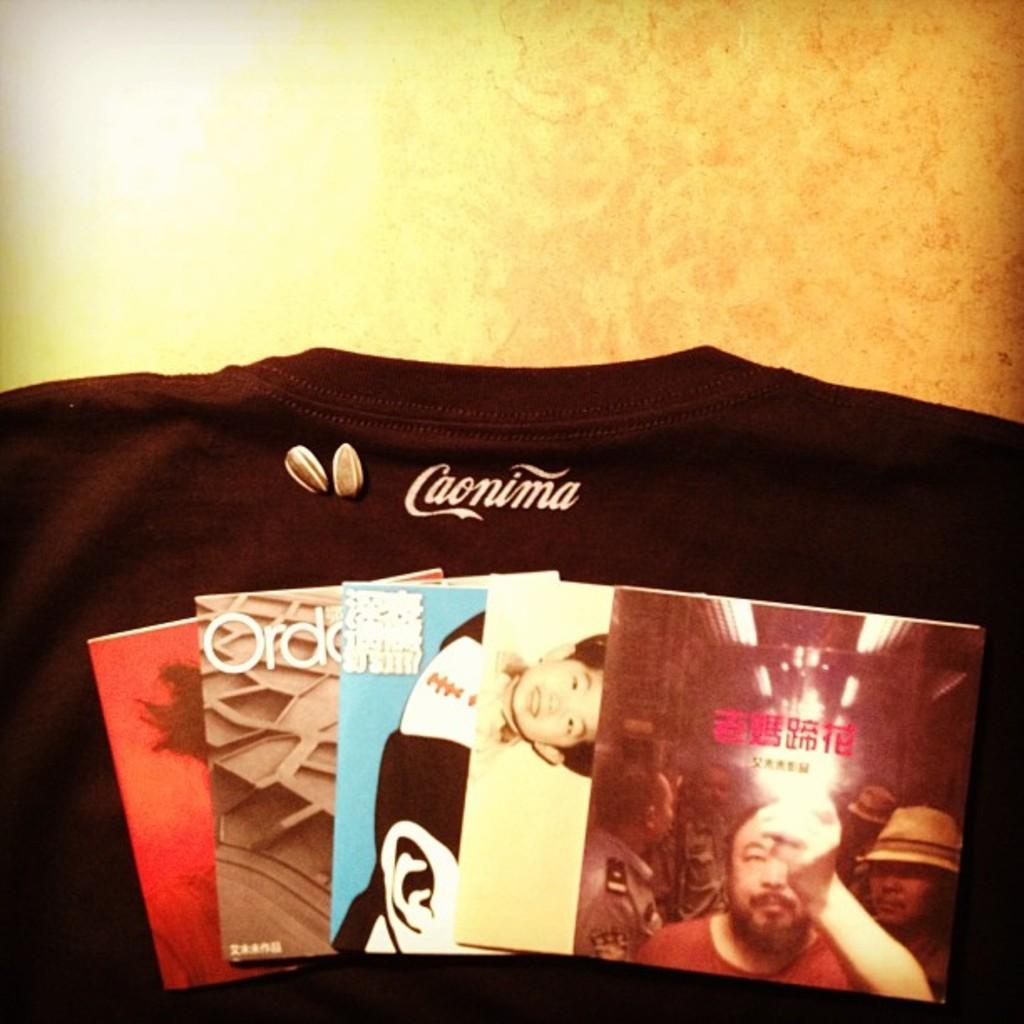Could you give a brief overview of what you see in this image? In this image we can see a t-shirt and some cards with some pictures on them which are placed on the surface. 